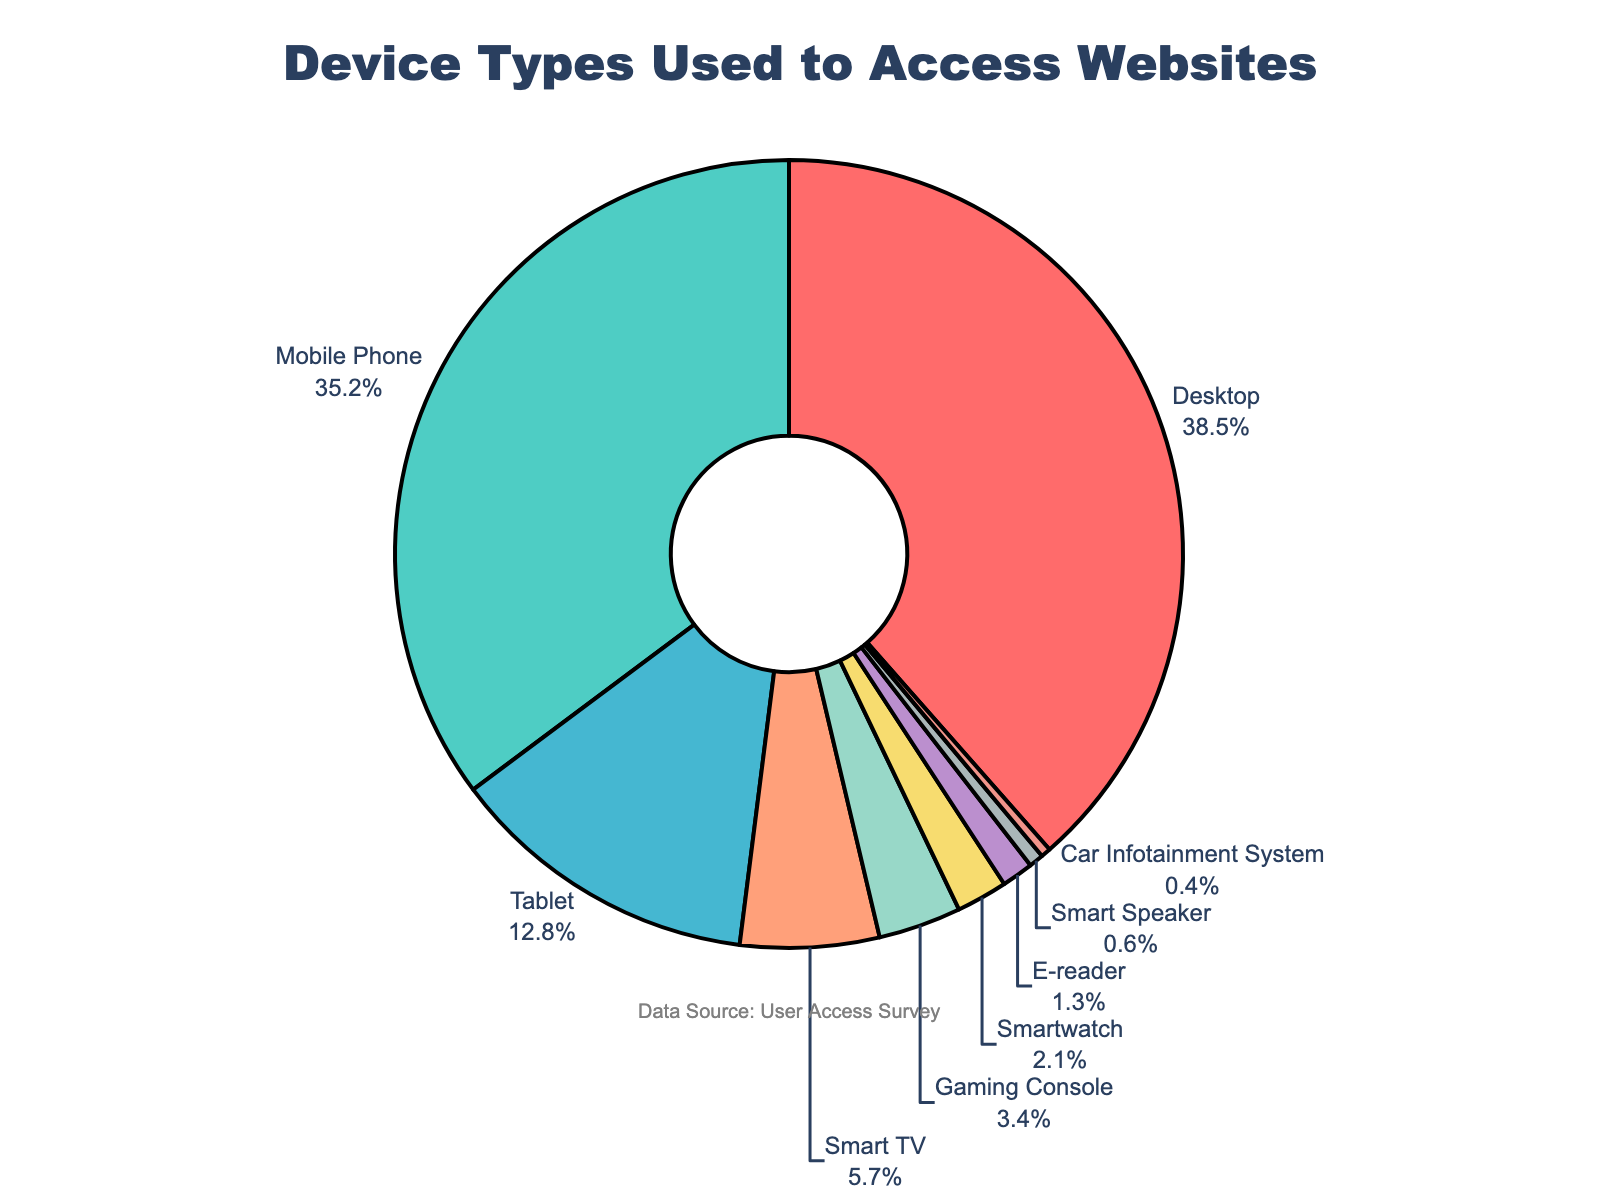Which device type has the highest percentage of user access? The pie chart shows that the Desktop slice is the largest.
Answer: Desktop What is the combined percentage of users accessing the website from Mobile Phones and Tablets? The percentage for Mobile Phones is 35.2% and for Tablets is 12.8%. Summing these values, 35.2 + 12.8 = 48.0%.
Answer: 48.0% What is the difference in user access percentage between Desktops and Smart TVs? The percentage for Desktops is 38.5% and for Smart TVs is 5.7%. Subtracting these values, 38.5 - 5.7 = 32.8%.
Answer: 32.8% Which device types have a lower user access percentage than Smartwatches? The pie chart shows that Smart Speaker, Car Infotainment System, and E-reader slices are smaller than the Smartwatch slice.
Answer: Smart Speaker, Car Infotainment System, E-reader What is the percentage of users who do not access the website from Desktop or Mobile Phone? The total percentage for Desktop and Mobile Phone is 38.5 + 35.2 = 73.7%. Therefore, the remaining percentage is 100 - 73.7 = 26.3%.
Answer: 26.3% What is the sum of the percentages of the least used three device types? The least used three device types are Car Infotainment System (0.4%), Smart Speaker (0.6%), and E-reader (1.3%). Summing these values, 0.4 + 0.6 + 1.3 = 2.3%.
Answer: 2.3% Is the percentage of users accessing the website from Mobile Phones greater than those accessing from Tablets and Smart TVs combined? The percentage for Mobile Phones is 35.2%. The combined percentage for Tablets (12.8%) and Smart TVs (5.7%) is 12.8 + 5.7 = 18.5%. Since 35.2 > 18.5, the answer is yes.
Answer: Yes What is the total percentage of users accessing the website from Smartwatch, E-reader, Smart Speaker, and Car Infotainment System? The respective percentages are Smartwatch (2.1%), E-reader (1.3%), Smart Speaker (0.6%), and Car Infotainment System (0.4%). Summing these values, 2.1 + 1.3 + 0.6 + 0.4 = 4.4%.
Answer: 4.4% Which device types have percentages that are multiples of the percentage for Gaming Consoles? The percentage for Gaming Consoles is 3.4%. No other percentages in the pie chart are exact multiples of 3.4.
Answer: None 